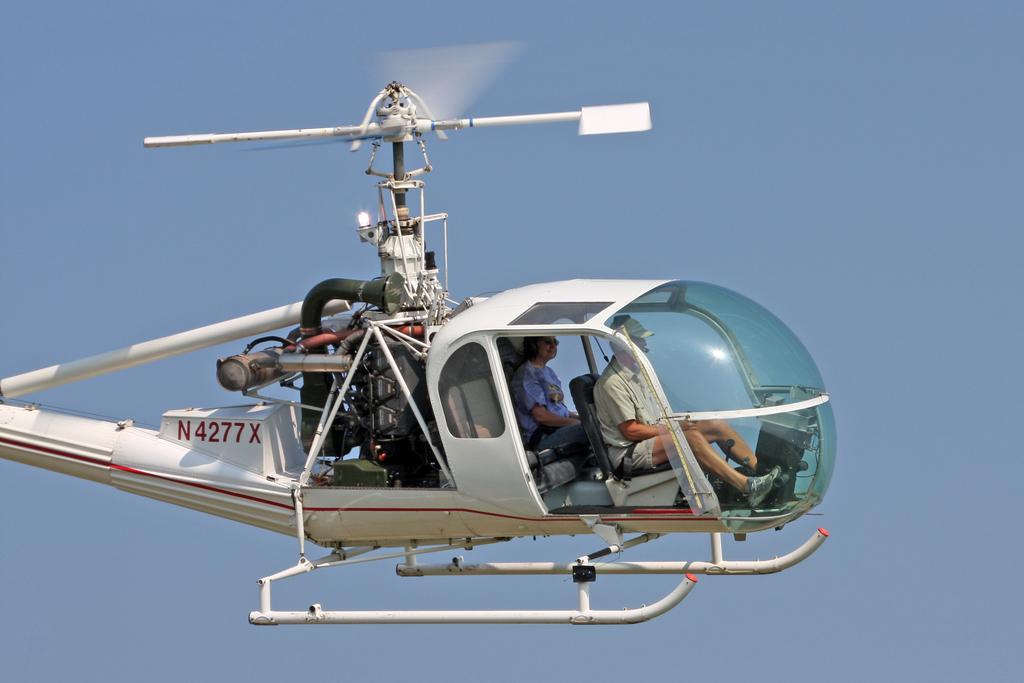What is the registration number on this helicopter?
Ensure brevity in your answer.  N4277x. 